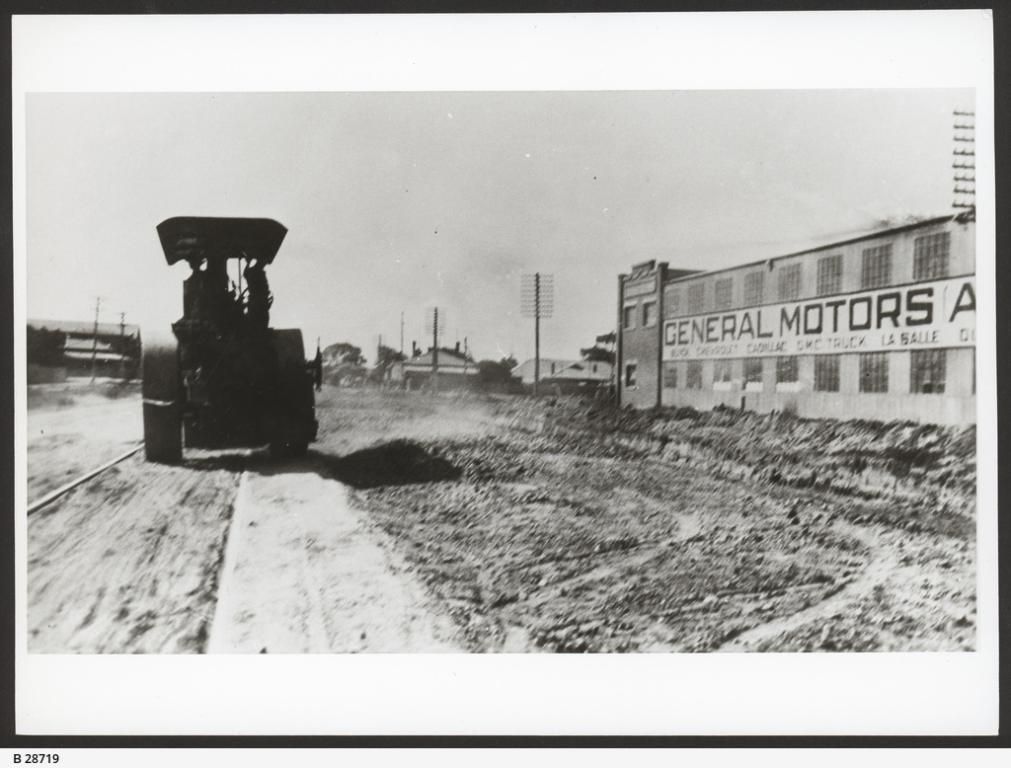What is the main subject of the image? There is a vehicle on the road in the image. What else can be seen in the image besides the vehicle? There are houses visible in the image. What type of channel can be seen running through the town in the image? There is no town or channel present in the image; it only features a vehicle on the road and houses in the background. 